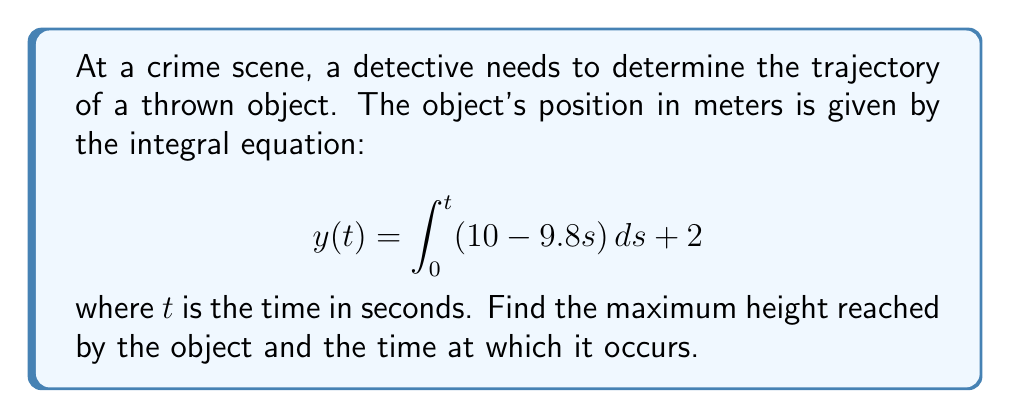Show me your answer to this math problem. 1. To solve this integral equation, we first need to evaluate the integral:

   $$y(t) = \int_0^t (10 - 9.8s) ds + 2$$
   $$y(t) = [10s - 4.9s^2]_0^t + 2$$
   $$y(t) = 10t - 4.9t^2 + 2$$

2. Now we have the position function $y(t)$. To find the maximum height, we need to find where the velocity is zero:

   $$v(t) = \frac{dy}{dt} = 10 - 9.8t$$

3. Set velocity to zero and solve for t:

   $$10 - 9.8t = 0$$
   $$9.8t = 10$$
   $$t = \frac{10}{9.8} \approx 1.02 \text{ seconds}$$

4. To find the maximum height, substitute this time back into the position function:

   $$y(1.02) = 10(1.02) - 4.9(1.02)^2 + 2$$
   $$y(1.02) = 10.2 - 5.1 + 2 = 7.1 \text{ meters}$$

5. Therefore, the maximum height is approximately 7.1 meters, occurring at about 1.02 seconds after the object is thrown.
Answer: Maximum height: 7.1 m; Time: 1.02 s 